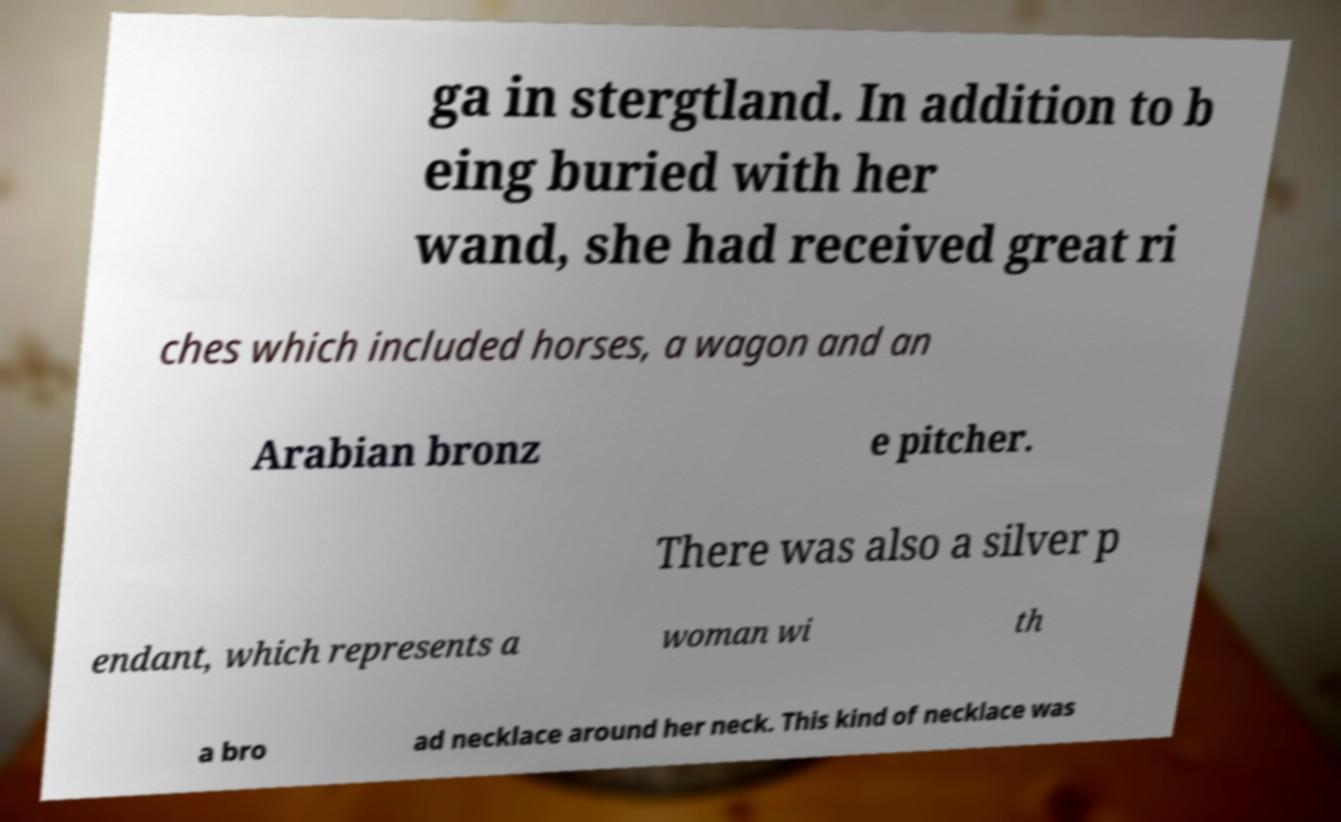Can you accurately transcribe the text from the provided image for me? ga in stergtland. In addition to b eing buried with her wand, she had received great ri ches which included horses, a wagon and an Arabian bronz e pitcher. There was also a silver p endant, which represents a woman wi th a bro ad necklace around her neck. This kind of necklace was 